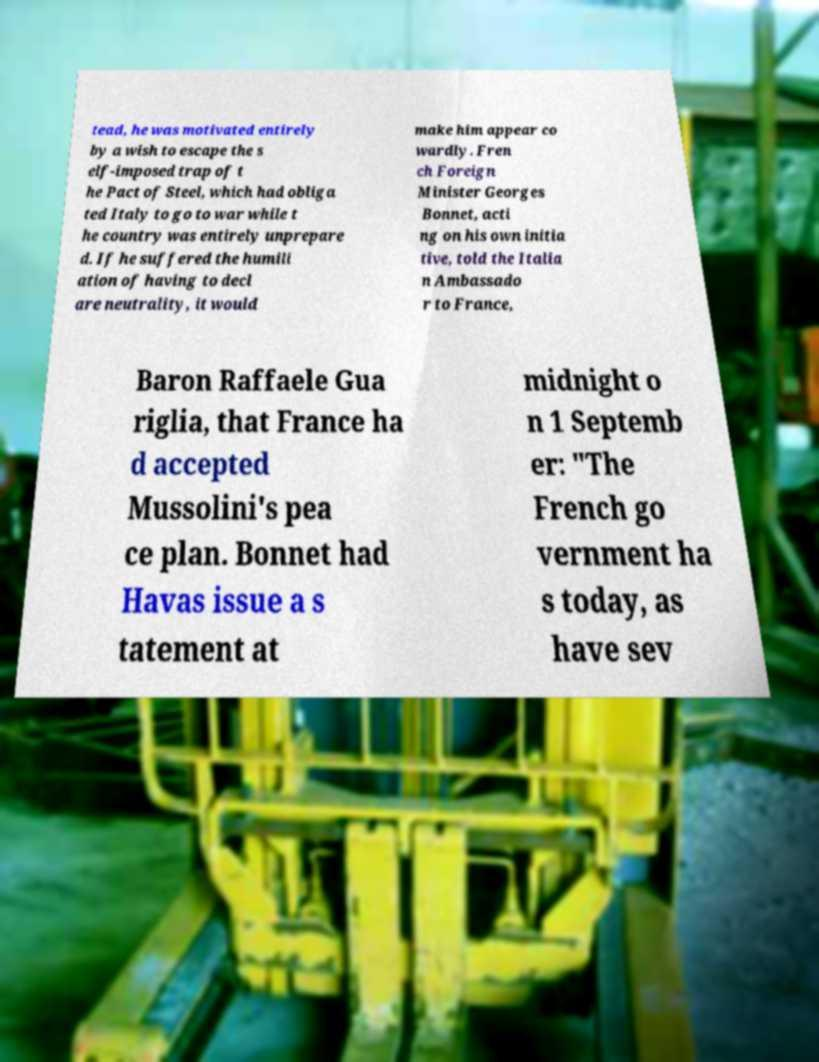I need the written content from this picture converted into text. Can you do that? tead, he was motivated entirely by a wish to escape the s elf-imposed trap of t he Pact of Steel, which had obliga ted Italy to go to war while t he country was entirely unprepare d. If he suffered the humili ation of having to decl are neutrality, it would make him appear co wardly. Fren ch Foreign Minister Georges Bonnet, acti ng on his own initia tive, told the Italia n Ambassado r to France, Baron Raffaele Gua riglia, that France ha d accepted Mussolini's pea ce plan. Bonnet had Havas issue a s tatement at midnight o n 1 Septemb er: "The French go vernment ha s today, as have sev 